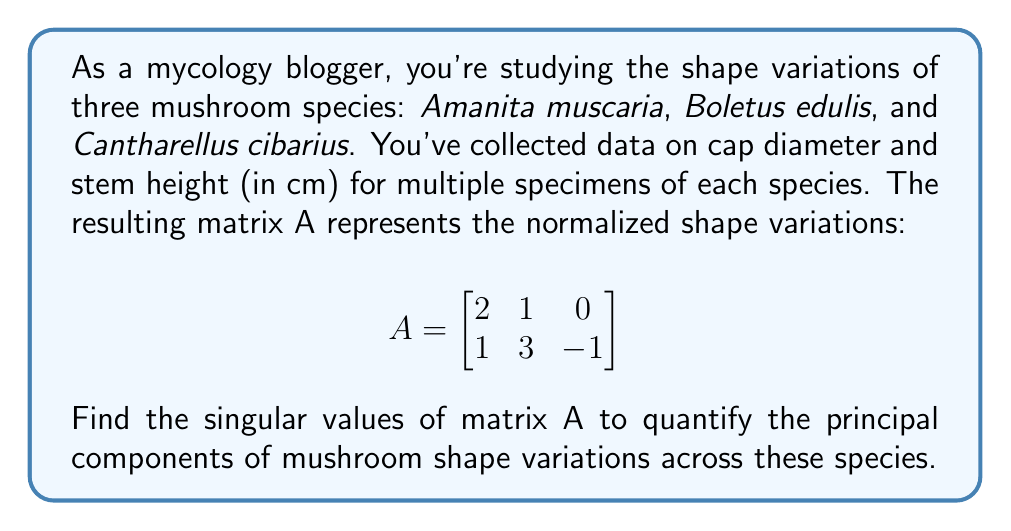Help me with this question. To find the singular values of matrix A, we'll follow these steps:

1) First, we need to calculate $A^TA$:

   $$A^TA = \begin{bmatrix}
   2 & 1 \\
   1 & 3 \\
   0 & -1
   \end{bmatrix} \begin{bmatrix}
   2 & 1 & 0 \\
   1 & 3 & -1
   \end{bmatrix} = \begin{bmatrix}
   5 & 5 & -1 \\
   5 & 10 & -3 \\
   -1 & -3 & 1
   \end{bmatrix}$$

2) The singular values are the square roots of the eigenvalues of $A^TA$. So, we need to find the eigenvalues by solving the characteristic equation:

   $$det(A^TA - \lambda I) = 0$$

3) Expanding this determinant:

   $$\begin{vmatrix}
   5-\lambda & 5 & -1 \\
   5 & 10-\lambda & -3 \\
   -1 & -3 & 1-\lambda
   \end{vmatrix} = 0$$

4) This expands to the cubic equation:

   $$-\lambda^3 + 16\lambda^2 - 55\lambda + 0 = 0$$

5) Factoring this equation:

   $$-\lambda(\lambda^2 - 16\lambda + 55) = 0$$
   $$-\lambda(\lambda - 11)(\lambda - 5) = 0$$

6) The eigenvalues are thus $\lambda_1 = 11$, $\lambda_2 = 5$, and $\lambda_3 = 0$.

7) The singular values are the square roots of these eigenvalues:

   $$\sigma_1 = \sqrt{11} \approx 3.32$$
   $$\sigma_2 = \sqrt{5} \approx 2.24$$
   $$\sigma_3 = 0$$

These singular values represent the significance of each principal component in the mushroom shape variations across the studied species.
Answer: $\sigma_1 \approx 3.32$, $\sigma_2 \approx 2.24$, $\sigma_3 = 0$ 